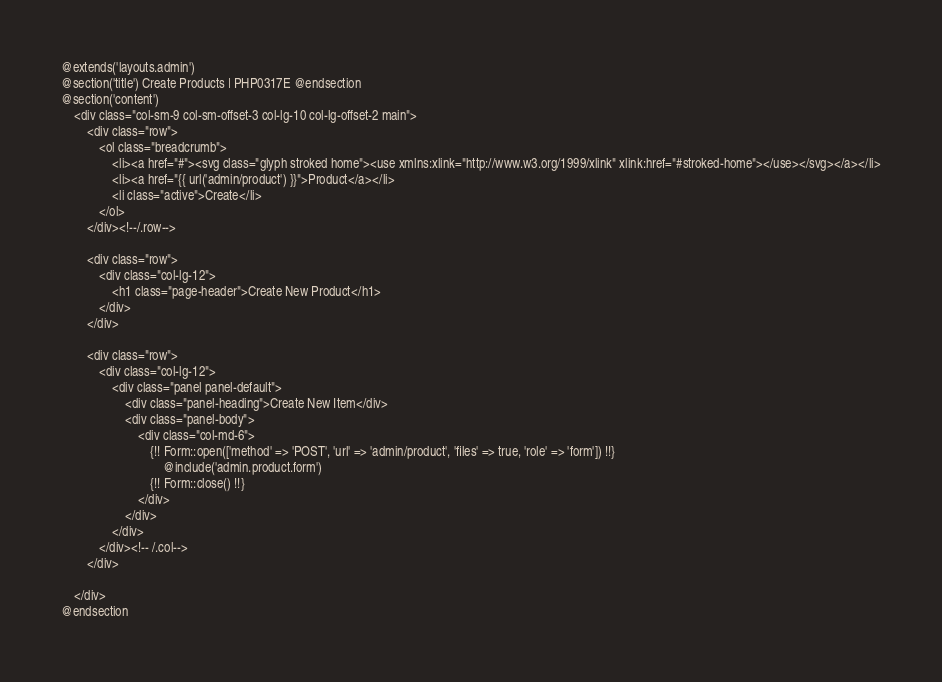<code> <loc_0><loc_0><loc_500><loc_500><_PHP_>@extends('layouts.admin')
@section('title') Create Products | PHP0317E @endsection
@section('content')
    <div class="col-sm-9 col-sm-offset-3 col-lg-10 col-lg-offset-2 main">
        <div class="row">
            <ol class="breadcrumb">
                <li><a href="#"><svg class="glyph stroked home"><use xmlns:xlink="http://www.w3.org/1999/xlink" xlink:href="#stroked-home"></use></svg></a></li>
                <li><a href="{{ url('admin/product') }}">Product</a></li>
                <li class="active">Create</li>
            </ol>
        </div><!--/.row-->

        <div class="row">
            <div class="col-lg-12">
                <h1 class="page-header">Create New Product</h1>
            </div>
        </div>

        <div class="row">
            <div class="col-lg-12">
                <div class="panel panel-default">
                    <div class="panel-heading">Create New Item</div>
                    <div class="panel-body">
                        <div class="col-md-6">
                            {!! Form::open(['method' => 'POST', 'url' => 'admin/product', 'files' => true, 'role' => 'form']) !!}
                                @include('admin.product.form')
                            {!! Form::close() !!}
                        </div>
                    </div>
                </div>
            </div><!-- /.col-->
        </div>

    </div>
@endsection</code> 